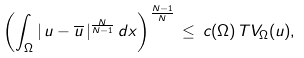Convert formula to latex. <formula><loc_0><loc_0><loc_500><loc_500>\left ( \int _ { \Omega } | \, u - \overline { u } \, | ^ { \frac { N } { N - 1 } } \, d x \right ) ^ { \frac { N - 1 } { N } } \, \leq \, c ( \Omega ) \, T V _ { \Omega } ( u ) ,</formula> 